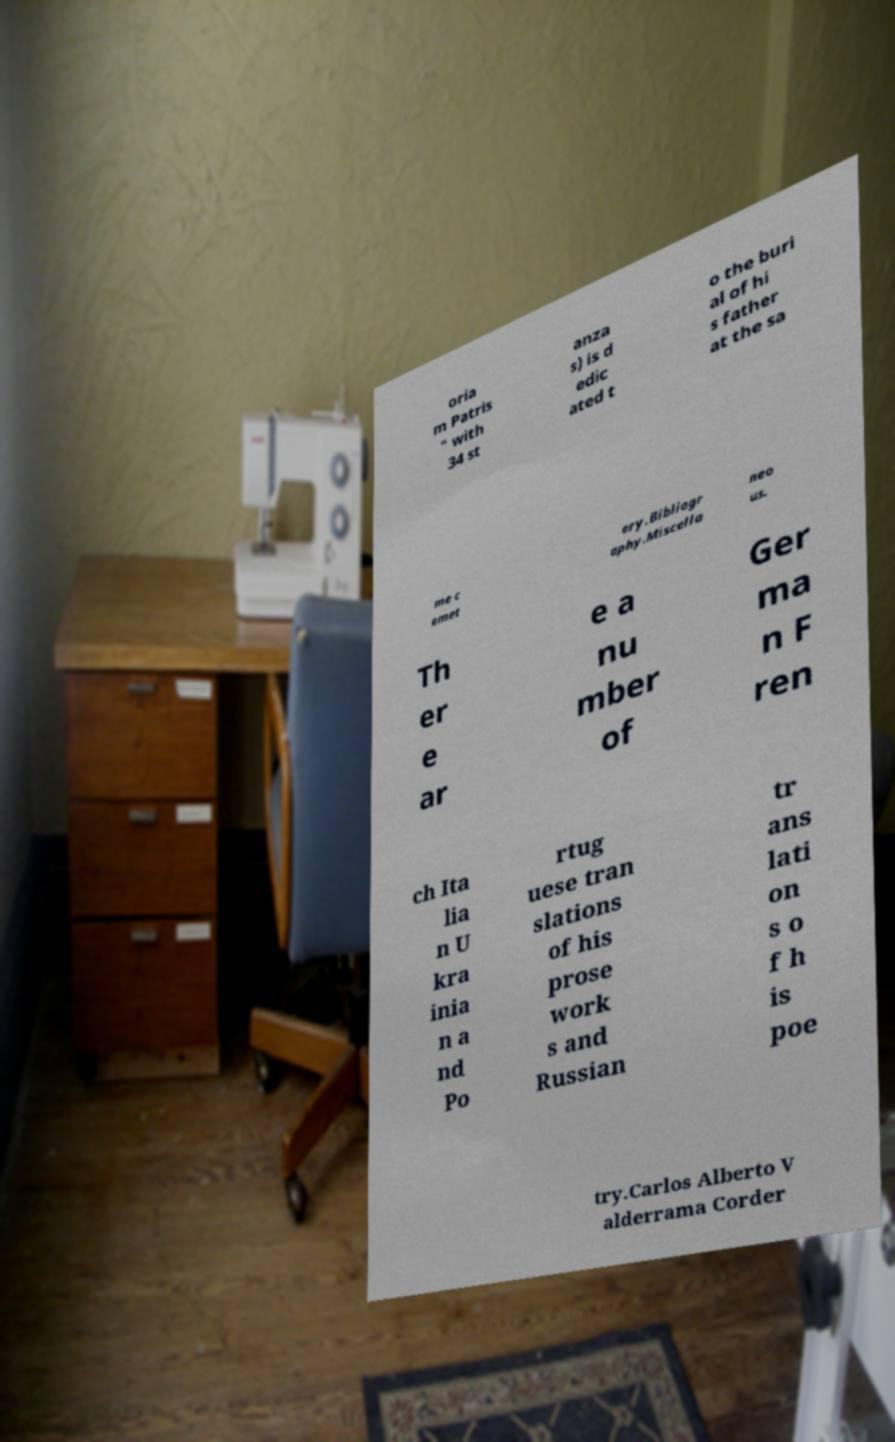There's text embedded in this image that I need extracted. Can you transcribe it verbatim? oria m Patris " with 34 st anza s) is d edic ated t o the buri al of hi s father at the sa me c emet ery.Bibliogr aphy.Miscella neo us. Th er e ar e a nu mber of Ger ma n F ren ch Ita lia n U kra inia n a nd Po rtug uese tran slations of his prose work s and Russian tr ans lati on s o f h is poe try.Carlos Alberto V alderrama Corder 